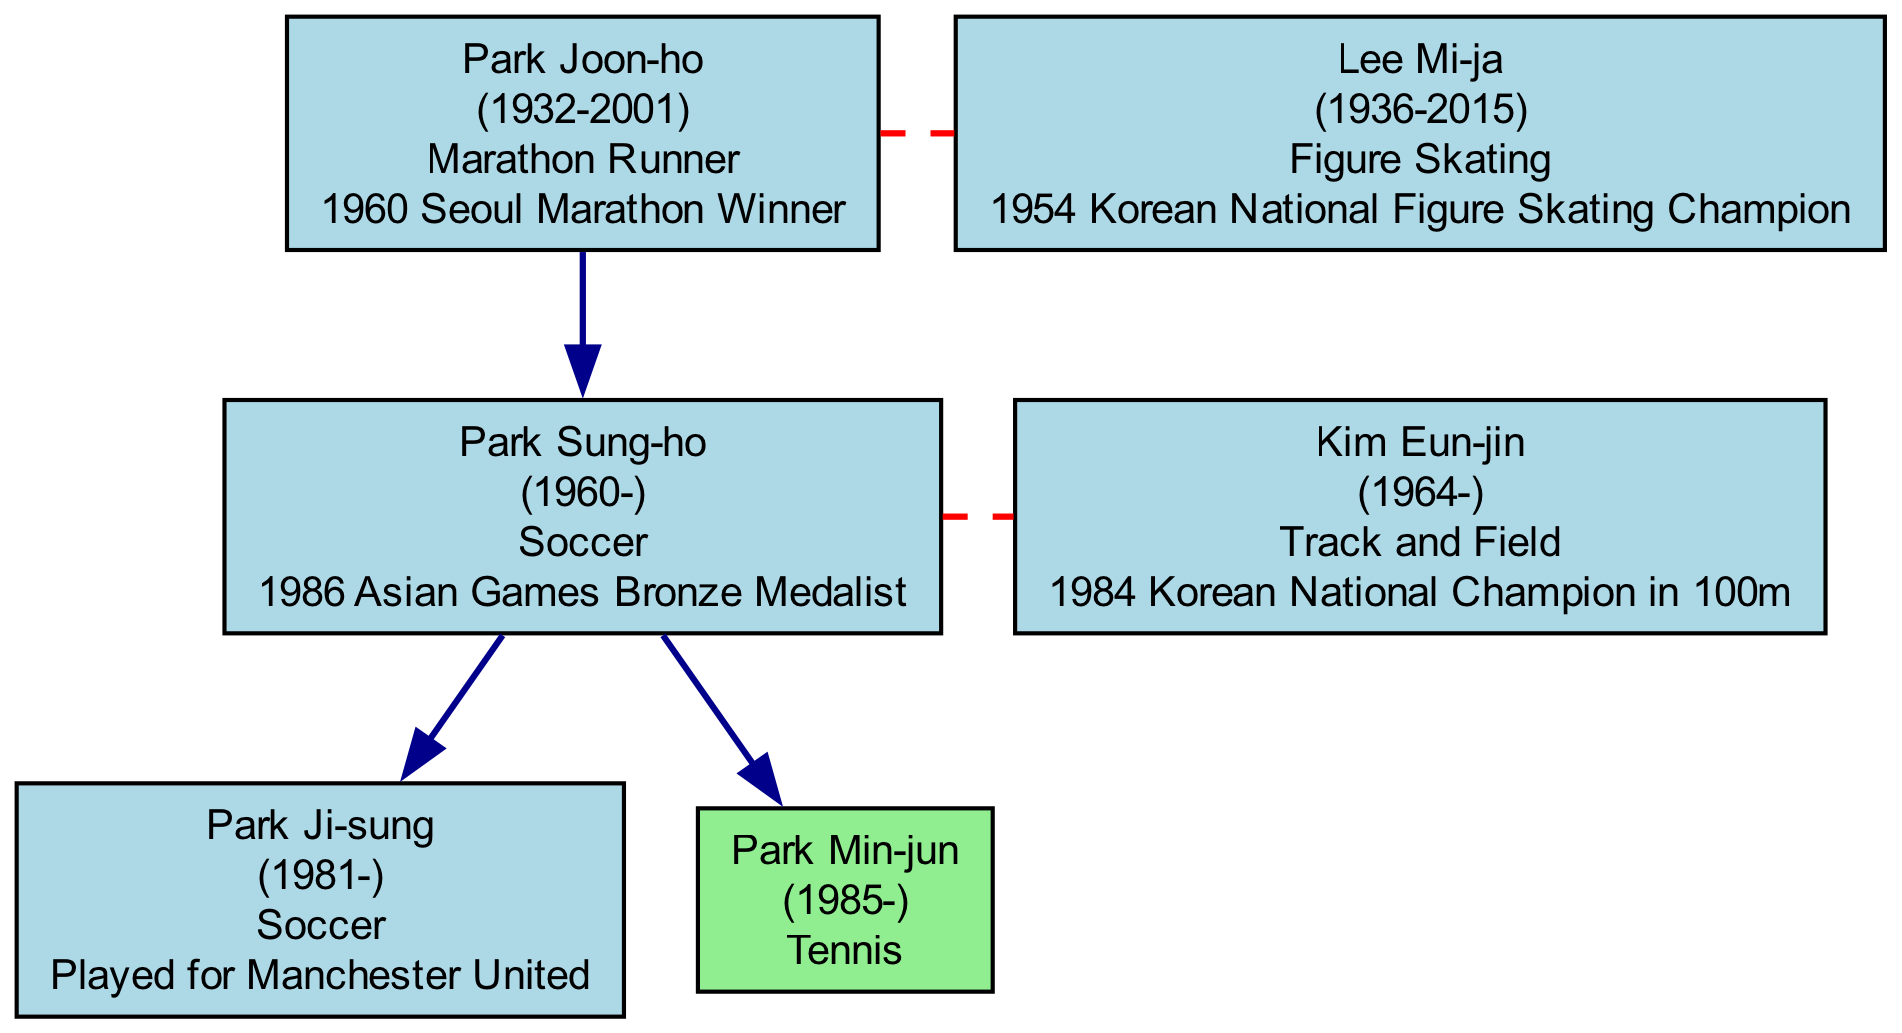What sport did Park Joon-ho participate in? The diagram shows that Park Joon-ho's sport is listed as "Marathon Runner."
Answer: Marathon Runner How many generations are represented in the Park family tree? The diagram indicates that there are three distinct generations depicted in the family tree.
Answer: 3 Who is the spouse of Park Sung-ho? According to the diagram, Park Sung-ho’s spouse is listed as Kim Eun-jin.
Answer: Kim Eun-jin What is Park Ji-sung's notable achievement? The diagram specifies that Park Ji-sung played for Manchester United, which is his notable achievement.
Answer: Played for Manchester United Which member of the Park family was a Figure Skating champion in 1954? The diagram indicates that Lee Mi-ja is noted for her achievement as the 1954 Korean National Figure Skating Champion.
Answer: Lee Mi-ja How is Park Min-jun related to Park Joon-ho? The diagram illustrates that Park Min-jun is the grandchild of Park Joon-ho.
Answer: Grandchild Is there a marital connection between Park Joon-ho and Lee Mi-ja? The diagram clearly shows that Park Joon-ho and Lee Mi-ja are connected as spouses.
Answer: Yes Which sport is represented twice in different generations? The diagram reveals that Soccer is represented by both Park Sung-ho and Park Ji-sung across generations.
Answer: Soccer What year did Lee Mi-ja pass away? The diagram states that Lee Mi-ja died in the year 2015.
Answer: 2015 